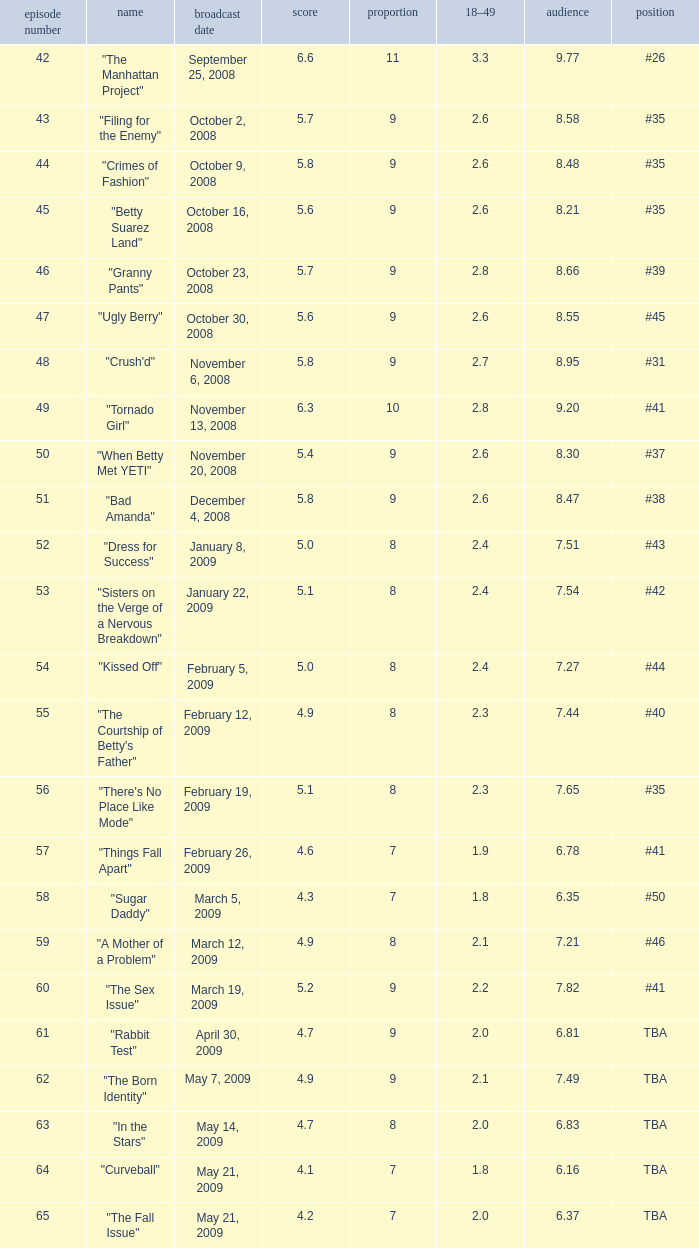What is the average Episode # with a share of 9, and #35 is rank and less than 8.21 viewers? None. 